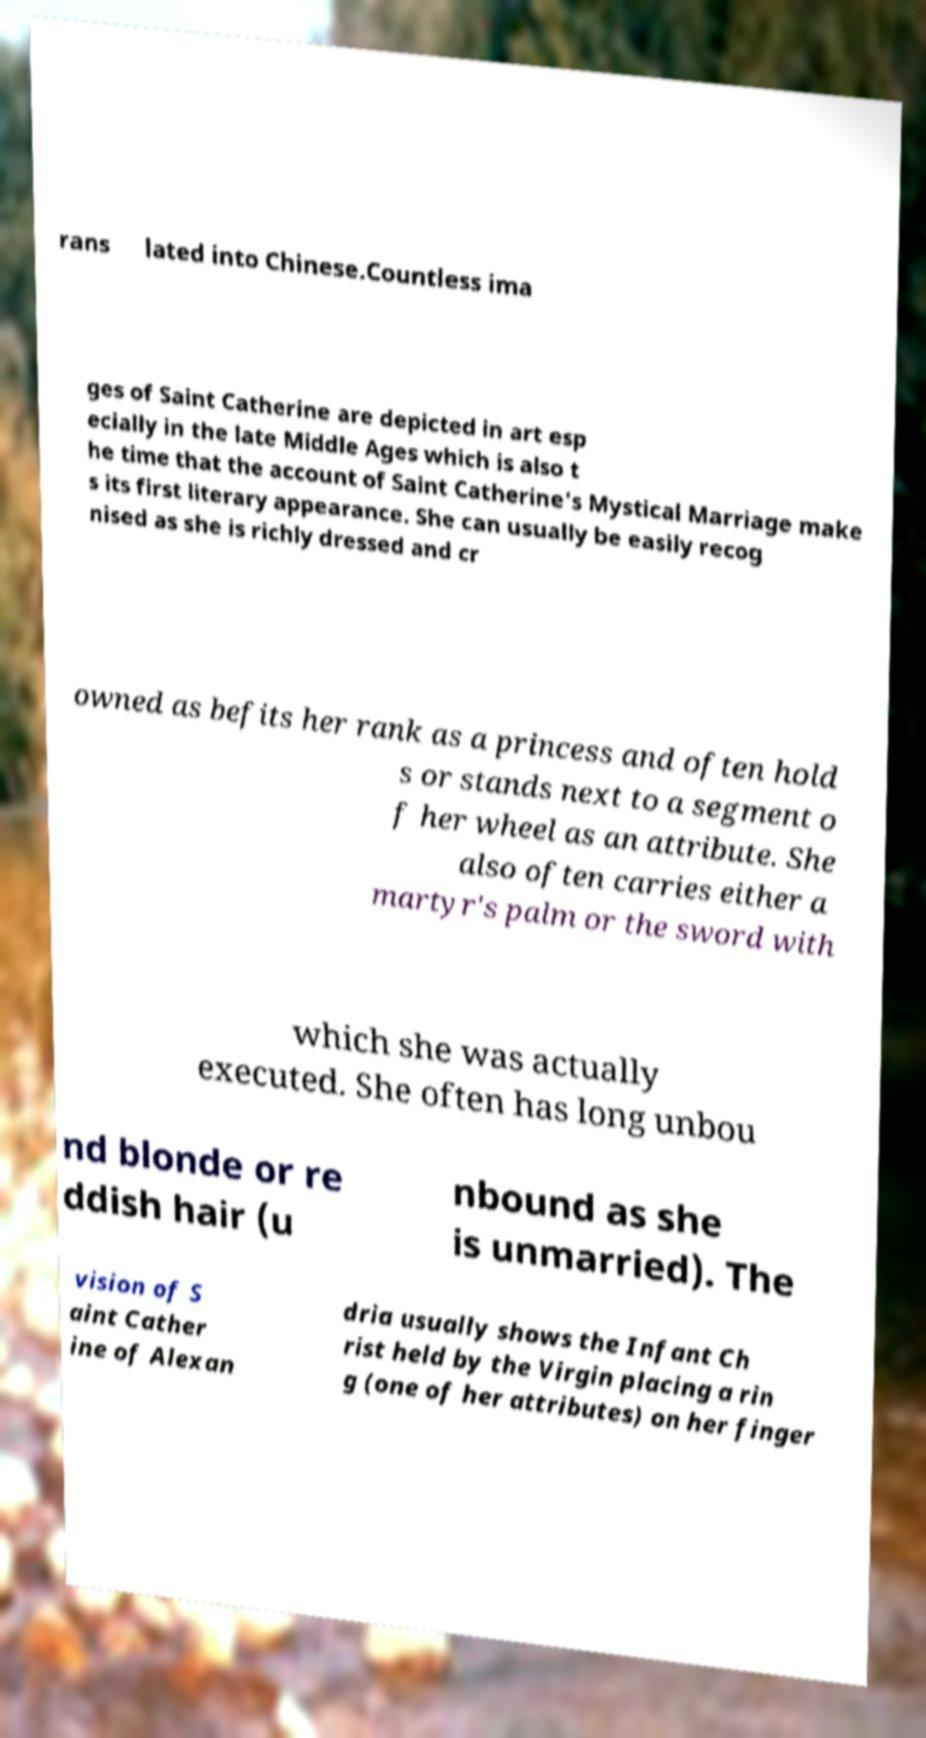Can you accurately transcribe the text from the provided image for me? rans lated into Chinese.Countless ima ges of Saint Catherine are depicted in art esp ecially in the late Middle Ages which is also t he time that the account of Saint Catherine's Mystical Marriage make s its first literary appearance. She can usually be easily recog nised as she is richly dressed and cr owned as befits her rank as a princess and often hold s or stands next to a segment o f her wheel as an attribute. She also often carries either a martyr's palm or the sword with which she was actually executed. She often has long unbou nd blonde or re ddish hair (u nbound as she is unmarried). The vision of S aint Cather ine of Alexan dria usually shows the Infant Ch rist held by the Virgin placing a rin g (one of her attributes) on her finger 